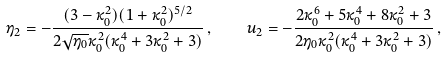<formula> <loc_0><loc_0><loc_500><loc_500>\eta _ { 2 } = - \frac { ( 3 - \kappa _ { 0 } ^ { 2 } ) ( 1 + \kappa _ { 0 } ^ { 2 } ) ^ { 5 / 2 } } { 2 \sqrt { \eta _ { 0 } } \kappa _ { 0 } ^ { 2 } ( \kappa _ { 0 } ^ { 4 } + 3 \kappa _ { 0 } ^ { 2 } + 3 ) } \, , \quad u _ { 2 } = - \frac { 2 \kappa _ { 0 } ^ { 6 } + 5 \kappa _ { 0 } ^ { 4 } + 8 \kappa _ { 0 } ^ { 2 } + 3 } { 2 \eta _ { 0 } \kappa _ { 0 } ^ { 2 } ( \kappa _ { 0 } ^ { 4 } + 3 \kappa _ { 0 } ^ { 2 } + 3 ) } \, ,</formula> 